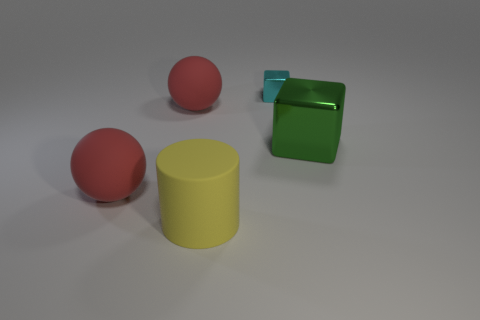Add 4 large brown cylinders. How many objects exist? 9 Subtract all green cubes. How many cubes are left? 1 Subtract all red cubes. Subtract all green spheres. How many cubes are left? 2 Subtract all red cubes. How many purple balls are left? 0 Subtract all tiny cyan things. Subtract all cyan cubes. How many objects are left? 3 Add 2 large cylinders. How many large cylinders are left? 3 Add 2 purple metal balls. How many purple metal balls exist? 2 Subtract 0 purple balls. How many objects are left? 5 Subtract all spheres. How many objects are left? 3 